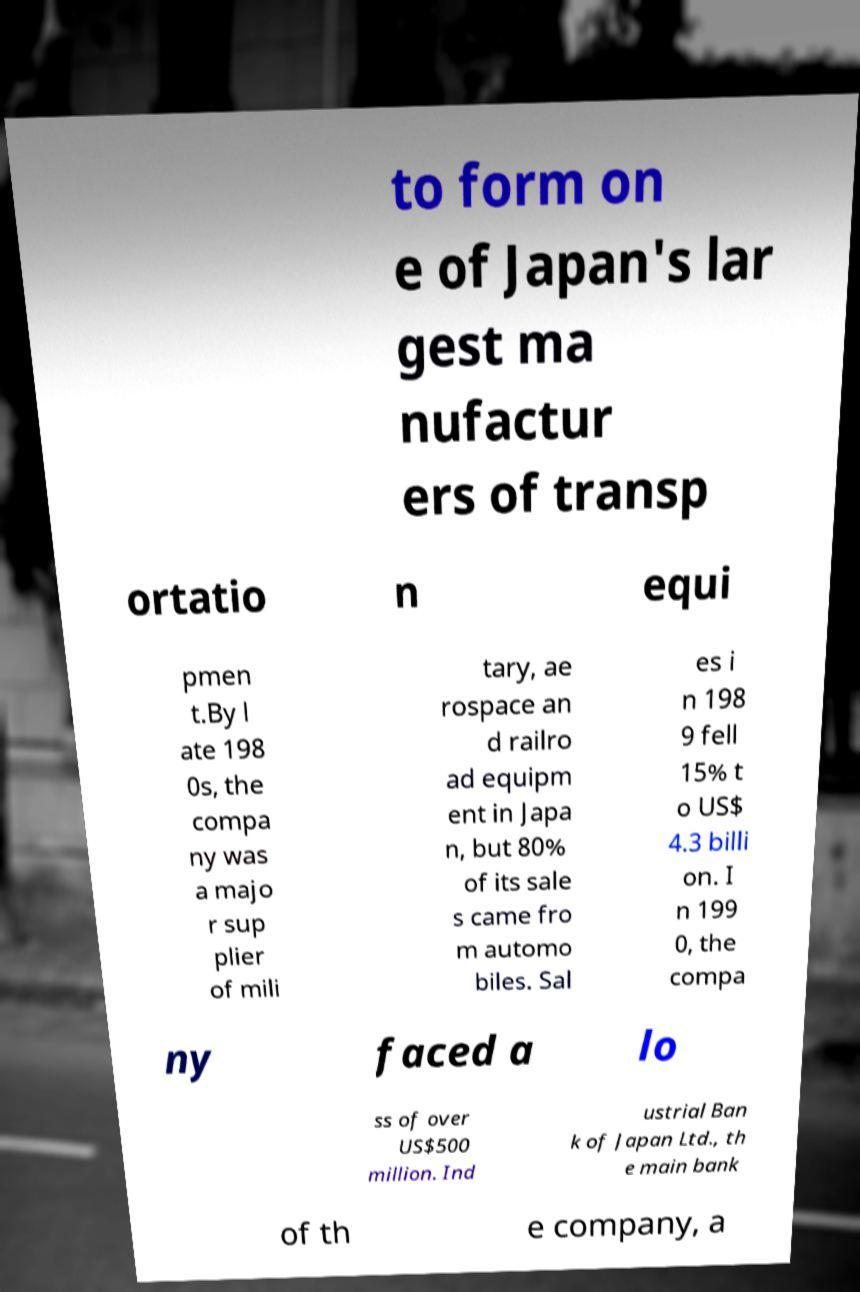Can you read and provide the text displayed in the image?This photo seems to have some interesting text. Can you extract and type it out for me? to form on e of Japan's lar gest ma nufactur ers of transp ortatio n equi pmen t.By l ate 198 0s, the compa ny was a majo r sup plier of mili tary, ae rospace an d railro ad equipm ent in Japa n, but 80% of its sale s came fro m automo biles. Sal es i n 198 9 fell 15% t o US$ 4.3 billi on. I n 199 0, the compa ny faced a lo ss of over US$500 million. Ind ustrial Ban k of Japan Ltd., th e main bank of th e company, a 